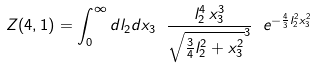<formula> <loc_0><loc_0><loc_500><loc_500>Z ( 4 , 1 ) = \int _ { 0 } ^ { \infty } d l _ { 2 } d x _ { 3 } \ \frac { l _ { 2 } ^ { 4 } \, x _ { 3 } ^ { 3 } } { \sqrt { \frac { 3 } { 4 } l _ { 2 } ^ { 2 } + x _ { 3 } ^ { 2 } } ^ { 3 } } \ e ^ { - \frac { 4 } { 3 } l _ { 2 } ^ { 2 } x _ { 3 } ^ { 2 } }</formula> 